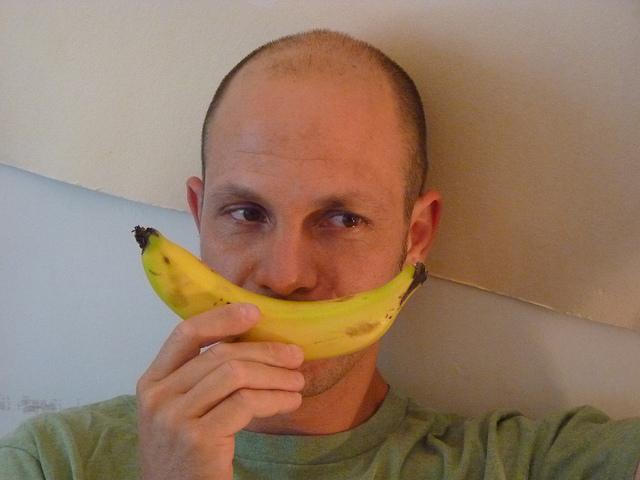Can the man use the banana as a mustache?
Be succinct. Yes. Is the end of the banana where it grew from the tree on the right or left?
Give a very brief answer. Right. What is he using the banana to do?
Answer briefly. Smile. Is the man smelling the banana?
Give a very brief answer. Yes. 